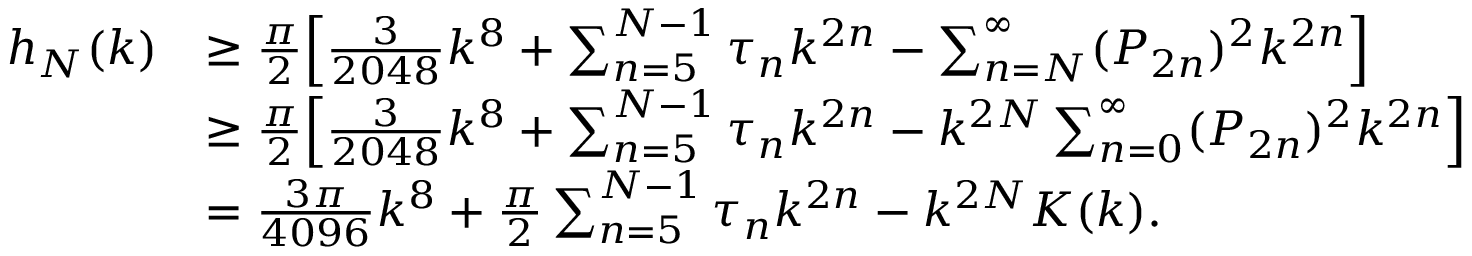Convert formula to latex. <formula><loc_0><loc_0><loc_500><loc_500>\begin{array} { r l } { h _ { N } ( k ) } & { \geq \frac { \pi } { 2 } \left [ \frac { 3 } { 2 0 4 8 } k ^ { 8 } + \sum _ { n = 5 } ^ { N - 1 } \tau _ { n } k ^ { 2 n } - \sum _ { n = N } ^ { \infty } ( P _ { 2 n } ) ^ { 2 } k ^ { 2 n } \right ] } \\ & { \geq \frac { \pi } { 2 } \left [ \frac { 3 } { 2 0 4 8 } k ^ { 8 } + \sum _ { n = 5 } ^ { N - 1 } \tau _ { n } k ^ { 2 n } - k ^ { 2 N } \sum _ { n = 0 } ^ { \infty } ( P _ { 2 n } ) ^ { 2 } k ^ { 2 n } \right ] } \\ & { = \frac { 3 \pi } { 4 0 9 6 } k ^ { 8 } + \frac { \pi } { 2 } \sum _ { n = 5 } ^ { N - 1 } \tau _ { n } k ^ { 2 n } - k ^ { 2 N } K ( k ) . } \end{array}</formula> 